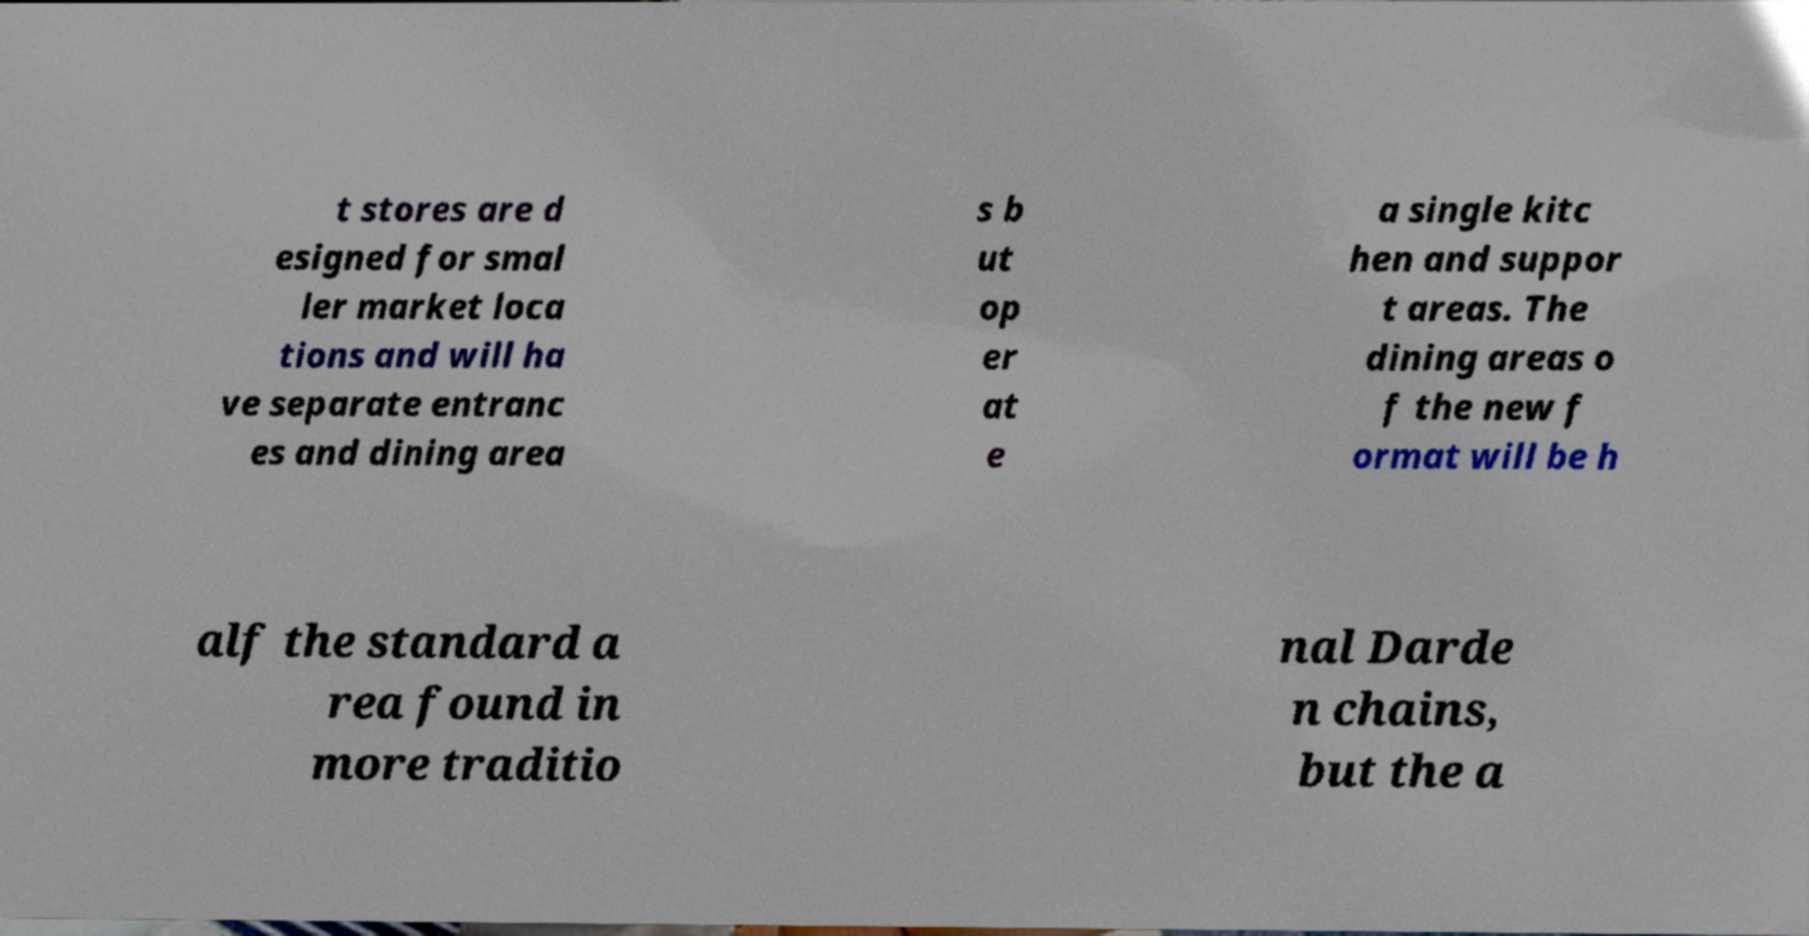Can you read and provide the text displayed in the image?This photo seems to have some interesting text. Can you extract and type it out for me? t stores are d esigned for smal ler market loca tions and will ha ve separate entranc es and dining area s b ut op er at e a single kitc hen and suppor t areas. The dining areas o f the new f ormat will be h alf the standard a rea found in more traditio nal Darde n chains, but the a 